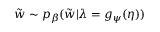Convert formula to latex. <formula><loc_0><loc_0><loc_500><loc_500>\tilde { w } \sim p _ { \beta } ( \tilde { w } | \lambda = g _ { \psi } ( \eta ) )</formula> 